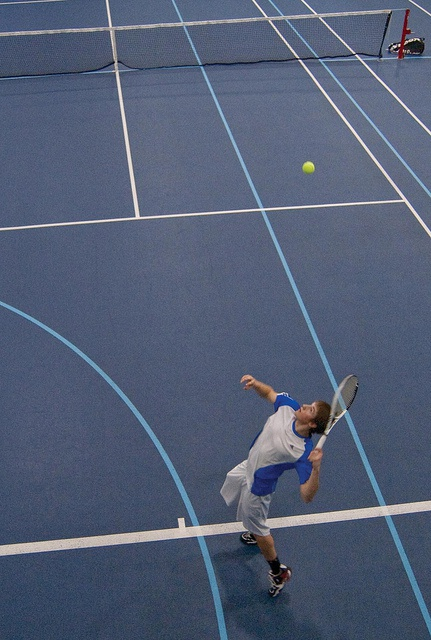Describe the objects in this image and their specific colors. I can see people in blue, gray, darkgray, navy, and black tones, tennis racket in blue, gray, darkgray, and black tones, and sports ball in blue, khaki, olive, and gray tones in this image. 